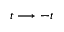Convert formula to latex. <formula><loc_0><loc_0><loc_500><loc_500>t \longrightarrow - t</formula> 